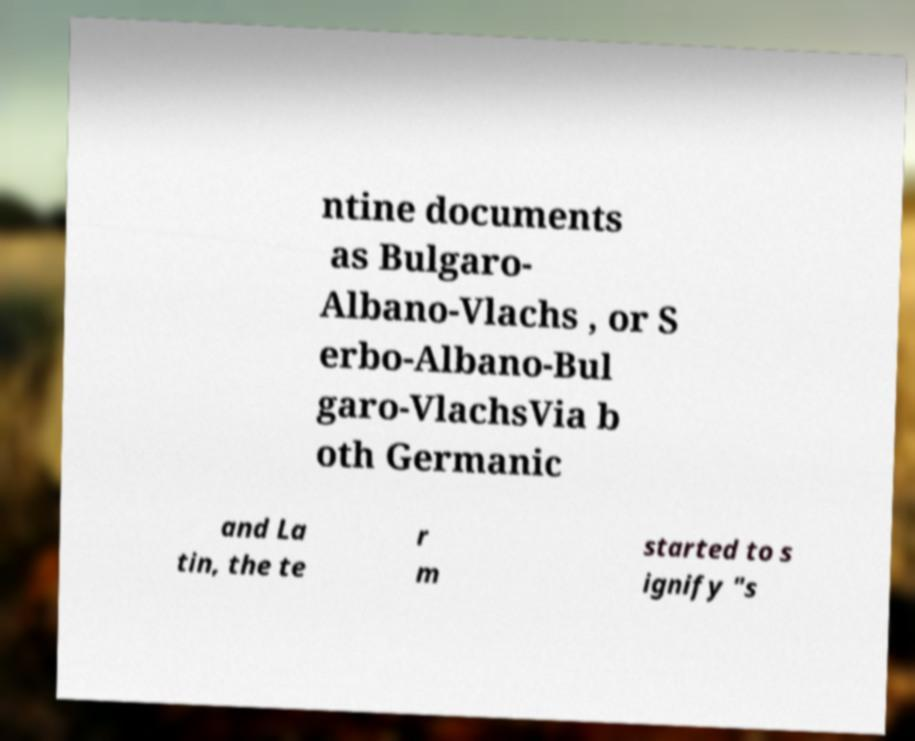Please identify and transcribe the text found in this image. ntine documents as Bulgaro- Albano-Vlachs , or S erbo-Albano-Bul garo-VlachsVia b oth Germanic and La tin, the te r m started to s ignify "s 